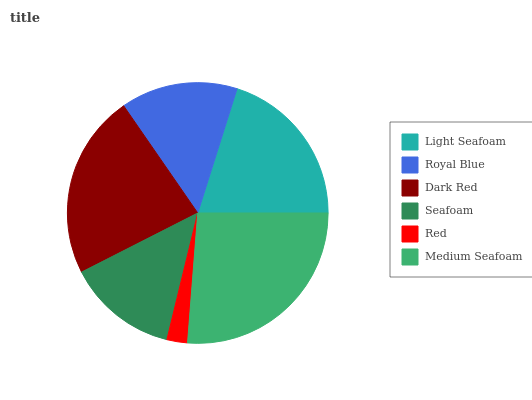Is Red the minimum?
Answer yes or no. Yes. Is Medium Seafoam the maximum?
Answer yes or no. Yes. Is Royal Blue the minimum?
Answer yes or no. No. Is Royal Blue the maximum?
Answer yes or no. No. Is Light Seafoam greater than Royal Blue?
Answer yes or no. Yes. Is Royal Blue less than Light Seafoam?
Answer yes or no. Yes. Is Royal Blue greater than Light Seafoam?
Answer yes or no. No. Is Light Seafoam less than Royal Blue?
Answer yes or no. No. Is Light Seafoam the high median?
Answer yes or no. Yes. Is Royal Blue the low median?
Answer yes or no. Yes. Is Dark Red the high median?
Answer yes or no. No. Is Seafoam the low median?
Answer yes or no. No. 